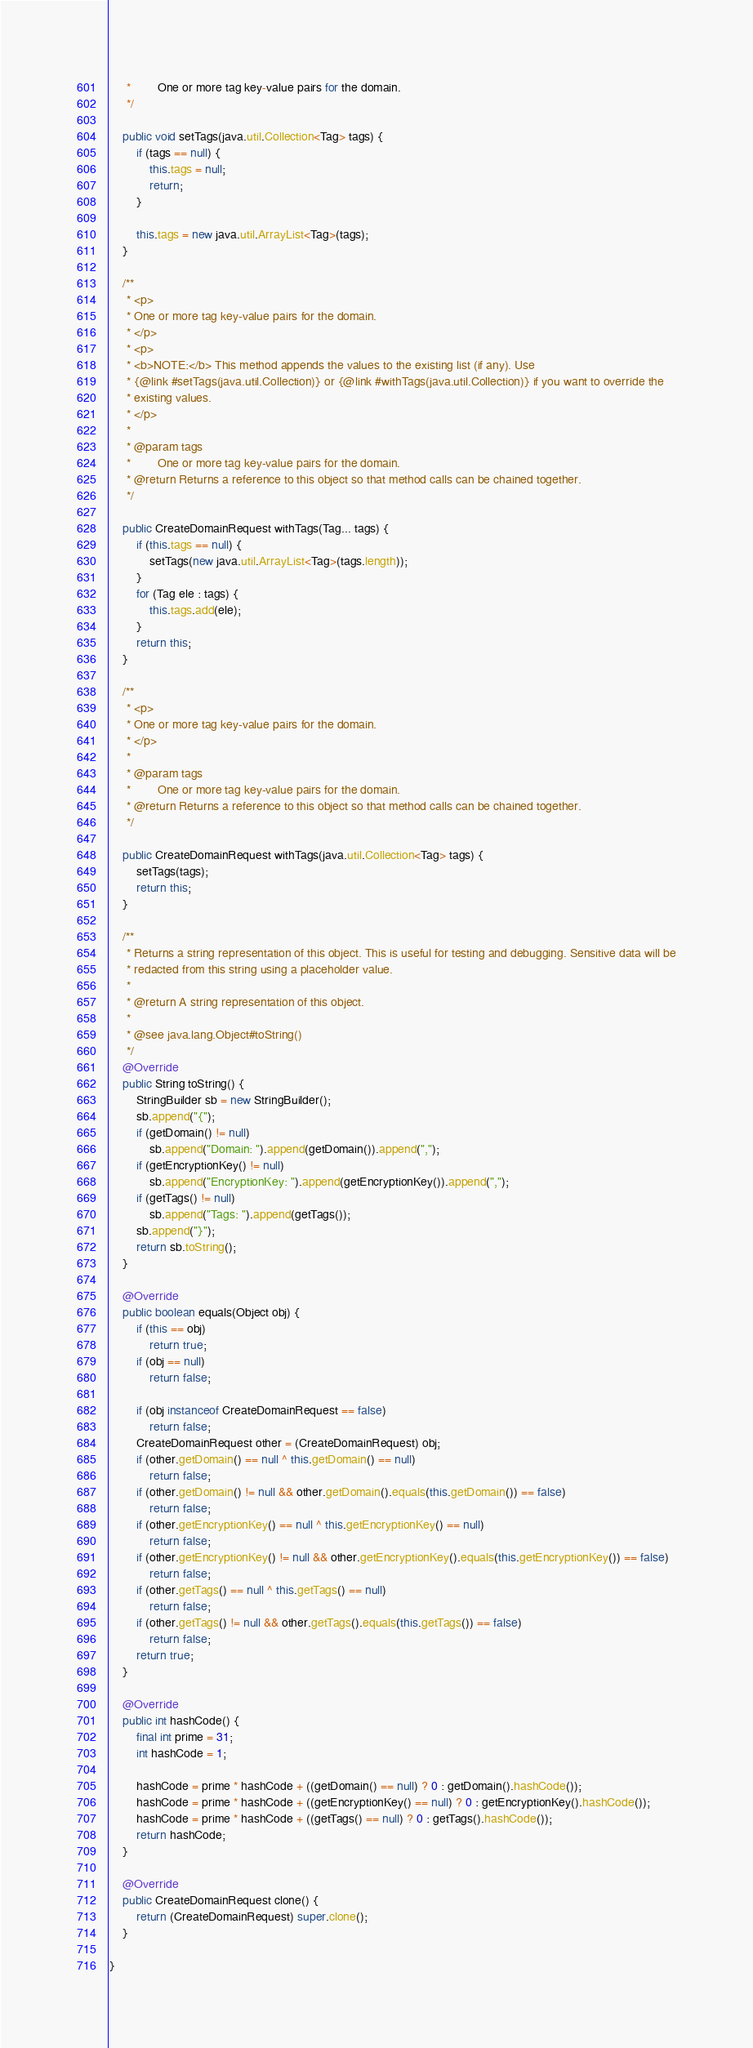<code> <loc_0><loc_0><loc_500><loc_500><_Java_>     *        One or more tag key-value pairs for the domain.
     */

    public void setTags(java.util.Collection<Tag> tags) {
        if (tags == null) {
            this.tags = null;
            return;
        }

        this.tags = new java.util.ArrayList<Tag>(tags);
    }

    /**
     * <p>
     * One or more tag key-value pairs for the domain.
     * </p>
     * <p>
     * <b>NOTE:</b> This method appends the values to the existing list (if any). Use
     * {@link #setTags(java.util.Collection)} or {@link #withTags(java.util.Collection)} if you want to override the
     * existing values.
     * </p>
     * 
     * @param tags
     *        One or more tag key-value pairs for the domain.
     * @return Returns a reference to this object so that method calls can be chained together.
     */

    public CreateDomainRequest withTags(Tag... tags) {
        if (this.tags == null) {
            setTags(new java.util.ArrayList<Tag>(tags.length));
        }
        for (Tag ele : tags) {
            this.tags.add(ele);
        }
        return this;
    }

    /**
     * <p>
     * One or more tag key-value pairs for the domain.
     * </p>
     * 
     * @param tags
     *        One or more tag key-value pairs for the domain.
     * @return Returns a reference to this object so that method calls can be chained together.
     */

    public CreateDomainRequest withTags(java.util.Collection<Tag> tags) {
        setTags(tags);
        return this;
    }

    /**
     * Returns a string representation of this object. This is useful for testing and debugging. Sensitive data will be
     * redacted from this string using a placeholder value.
     *
     * @return A string representation of this object.
     *
     * @see java.lang.Object#toString()
     */
    @Override
    public String toString() {
        StringBuilder sb = new StringBuilder();
        sb.append("{");
        if (getDomain() != null)
            sb.append("Domain: ").append(getDomain()).append(",");
        if (getEncryptionKey() != null)
            sb.append("EncryptionKey: ").append(getEncryptionKey()).append(",");
        if (getTags() != null)
            sb.append("Tags: ").append(getTags());
        sb.append("}");
        return sb.toString();
    }

    @Override
    public boolean equals(Object obj) {
        if (this == obj)
            return true;
        if (obj == null)
            return false;

        if (obj instanceof CreateDomainRequest == false)
            return false;
        CreateDomainRequest other = (CreateDomainRequest) obj;
        if (other.getDomain() == null ^ this.getDomain() == null)
            return false;
        if (other.getDomain() != null && other.getDomain().equals(this.getDomain()) == false)
            return false;
        if (other.getEncryptionKey() == null ^ this.getEncryptionKey() == null)
            return false;
        if (other.getEncryptionKey() != null && other.getEncryptionKey().equals(this.getEncryptionKey()) == false)
            return false;
        if (other.getTags() == null ^ this.getTags() == null)
            return false;
        if (other.getTags() != null && other.getTags().equals(this.getTags()) == false)
            return false;
        return true;
    }

    @Override
    public int hashCode() {
        final int prime = 31;
        int hashCode = 1;

        hashCode = prime * hashCode + ((getDomain() == null) ? 0 : getDomain().hashCode());
        hashCode = prime * hashCode + ((getEncryptionKey() == null) ? 0 : getEncryptionKey().hashCode());
        hashCode = prime * hashCode + ((getTags() == null) ? 0 : getTags().hashCode());
        return hashCode;
    }

    @Override
    public CreateDomainRequest clone() {
        return (CreateDomainRequest) super.clone();
    }

}
</code> 